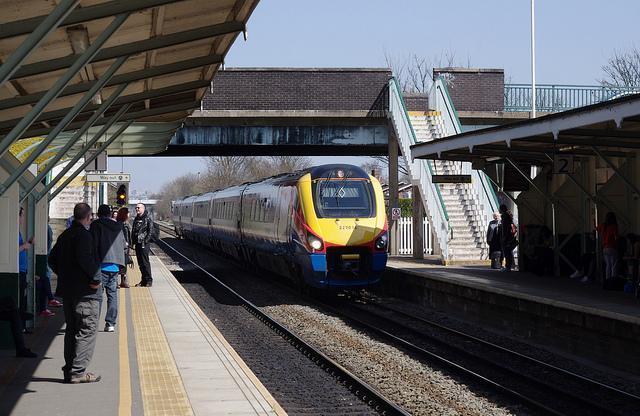Which platform services the train arriving now?
From the following set of four choices, select the accurate answer to respond to the question.
Options: Right, none, left, last one. Right. 